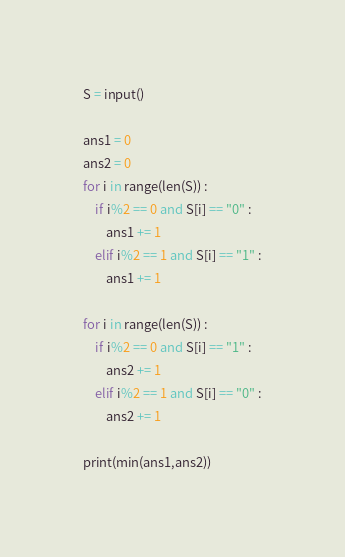Convert code to text. <code><loc_0><loc_0><loc_500><loc_500><_Python_>S = input()

ans1 = 0
ans2 = 0
for i in range(len(S)) :
    if i%2 == 0 and S[i] == "0" :
        ans1 += 1
    elif i%2 == 1 and S[i] == "1" :
        ans1 += 1

for i in range(len(S)) :
    if i%2 == 0 and S[i] == "1" :
        ans2 += 1
    elif i%2 == 1 and S[i] == "0" :
        ans2 += 1

print(min(ans1,ans2))
</code> 